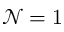Convert formula to latex. <formula><loc_0><loc_0><loc_500><loc_500>{ \mathcal { N } } = 1</formula> 